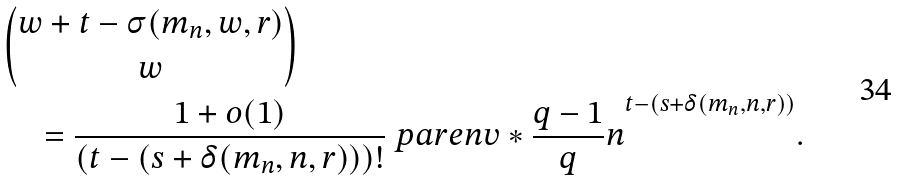Convert formula to latex. <formula><loc_0><loc_0><loc_500><loc_500>& \binom { w + t - \sigma ( m _ { n } , w , r ) } { w } \\ & \quad = \frac { 1 + o ( 1 ) } { ( t - ( s + \delta ( m _ { n } , n , r ) ) ) ! } \ p a r e n v * { \frac { q - 1 } { q } n } ^ { t - ( s + \delta ( m _ { n } , n , r ) ) } .</formula> 